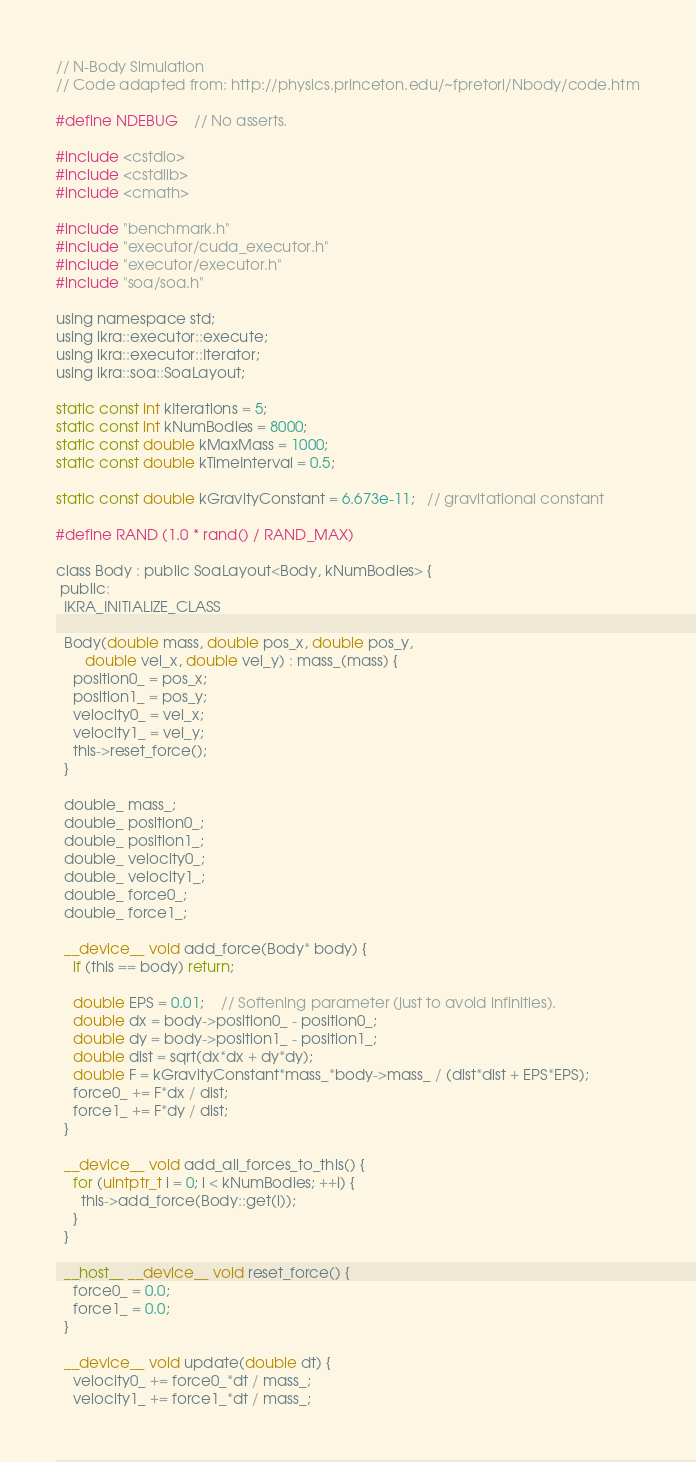<code> <loc_0><loc_0><loc_500><loc_500><_Cuda_>// N-Body Simulation
// Code adapted from: http://physics.princeton.edu/~fpretori/Nbody/code.htm

#define NDEBUG    // No asserts.

#include <cstdio>
#include <cstdlib>
#include <cmath>

#include "benchmark.h"
#include "executor/cuda_executor.h"
#include "executor/executor.h"
#include "soa/soa.h"

using namespace std;
using ikra::executor::execute;
using ikra::executor::Iterator;
using ikra::soa::SoaLayout;

static const int kIterations = 5;
static const int kNumBodies = 8000;
static const double kMaxMass = 1000;
static const double kTimeInterval = 0.5;

static const double kGravityConstant = 6.673e-11;   // gravitational constant

#define RAND (1.0 * rand() / RAND_MAX)

class Body : public SoaLayout<Body, kNumBodies> {
 public:
  IKRA_INITIALIZE_CLASS

  Body(double mass, double pos_x, double pos_y,
       double vel_x, double vel_y) : mass_(mass) {
    position0_ = pos_x;
    position1_ = pos_y;
    velocity0_ = vel_x;
    velocity1_ = vel_y;
    this->reset_force();
  }

  double_ mass_;
  double_ position0_;
  double_ position1_;
  double_ velocity0_;
  double_ velocity1_;
  double_ force0_;
  double_ force1_;

  __device__ void add_force(Body* body) {
    if (this == body) return;

    double EPS = 0.01;    // Softening parameter (just to avoid infinities).
    double dx = body->position0_ - position0_;
    double dy = body->position1_ - position1_;
    double dist = sqrt(dx*dx + dy*dy);
    double F = kGravityConstant*mass_*body->mass_ / (dist*dist + EPS*EPS);
    force0_ += F*dx / dist;
    force1_ += F*dy / dist;
  }

  __device__ void add_all_forces_to_this() {
    for (uintptr_t i = 0; i < kNumBodies; ++i) {
      this->add_force(Body::get(i));
    }
  }

  __host__ __device__ void reset_force() {
    force0_ = 0.0;
    force1_ = 0.0;
  }

  __device__ void update(double dt) {
    velocity0_ += force0_*dt / mass_;
    velocity1_ += force1_*dt / mass_;</code> 